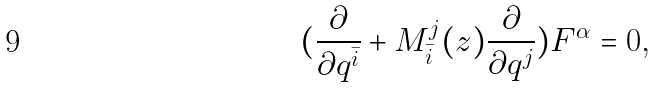Convert formula to latex. <formula><loc_0><loc_0><loc_500><loc_500>( \frac { \partial } { \partial q ^ { \bar { i } } } + M ^ { j } _ { \bar { i } } ( z ) \frac { \partial } { \partial q ^ { j } } ) F ^ { \alpha } = 0 ,</formula> 